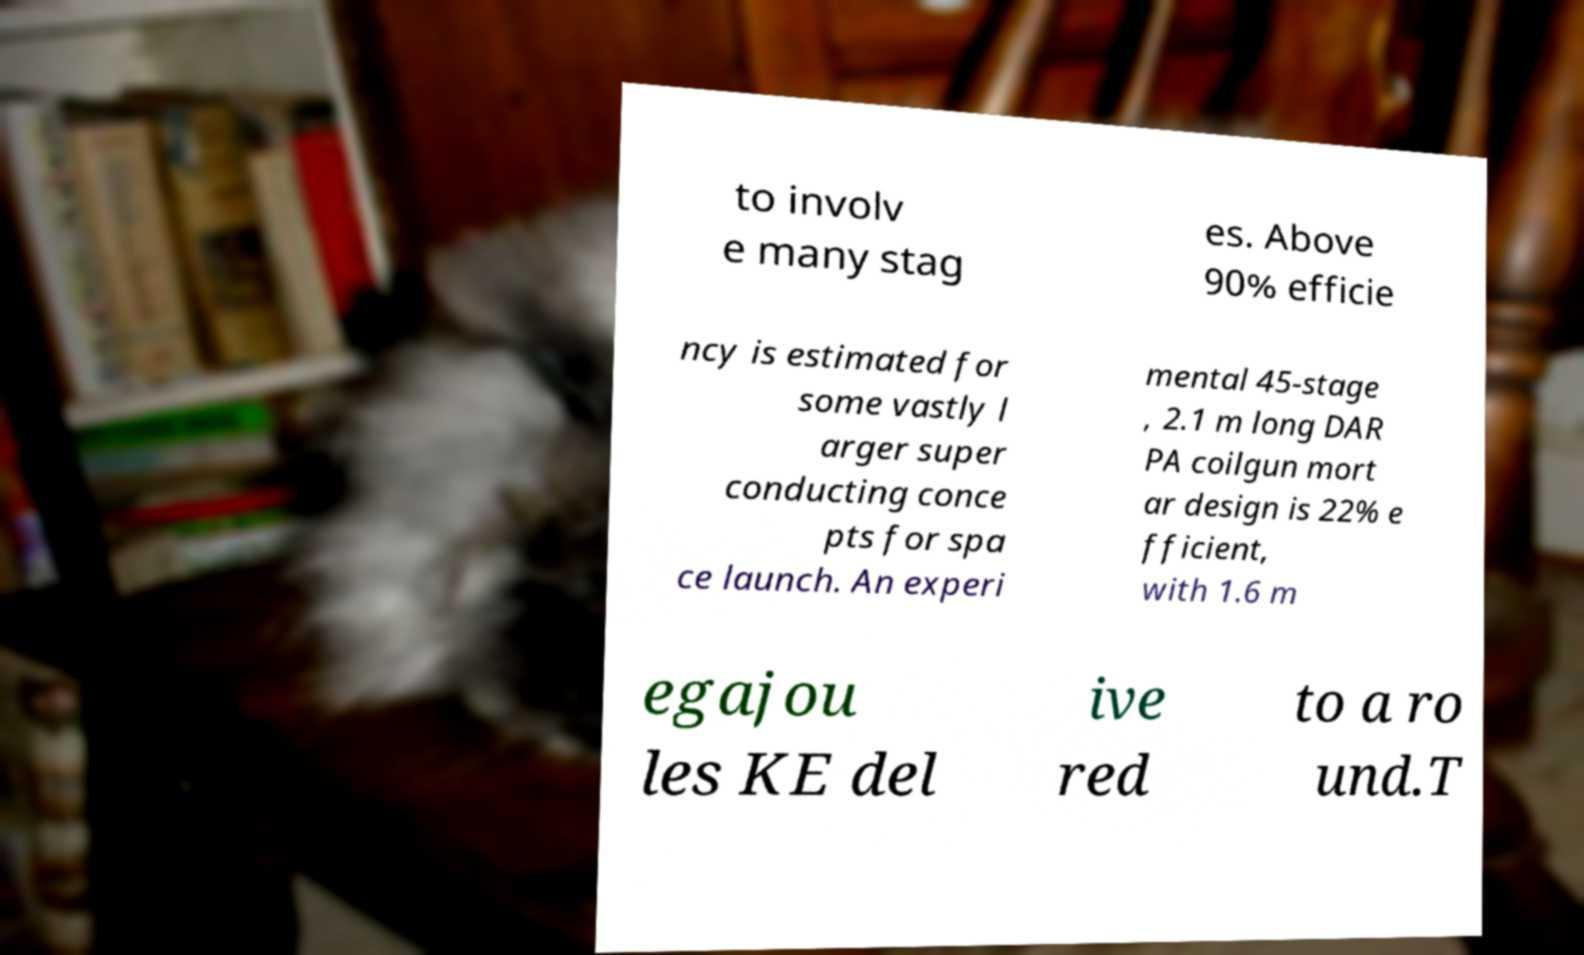There's text embedded in this image that I need extracted. Can you transcribe it verbatim? to involv e many stag es. Above 90% efficie ncy is estimated for some vastly l arger super conducting conce pts for spa ce launch. An experi mental 45-stage , 2.1 m long DAR PA coilgun mort ar design is 22% e fficient, with 1.6 m egajou les KE del ive red to a ro und.T 